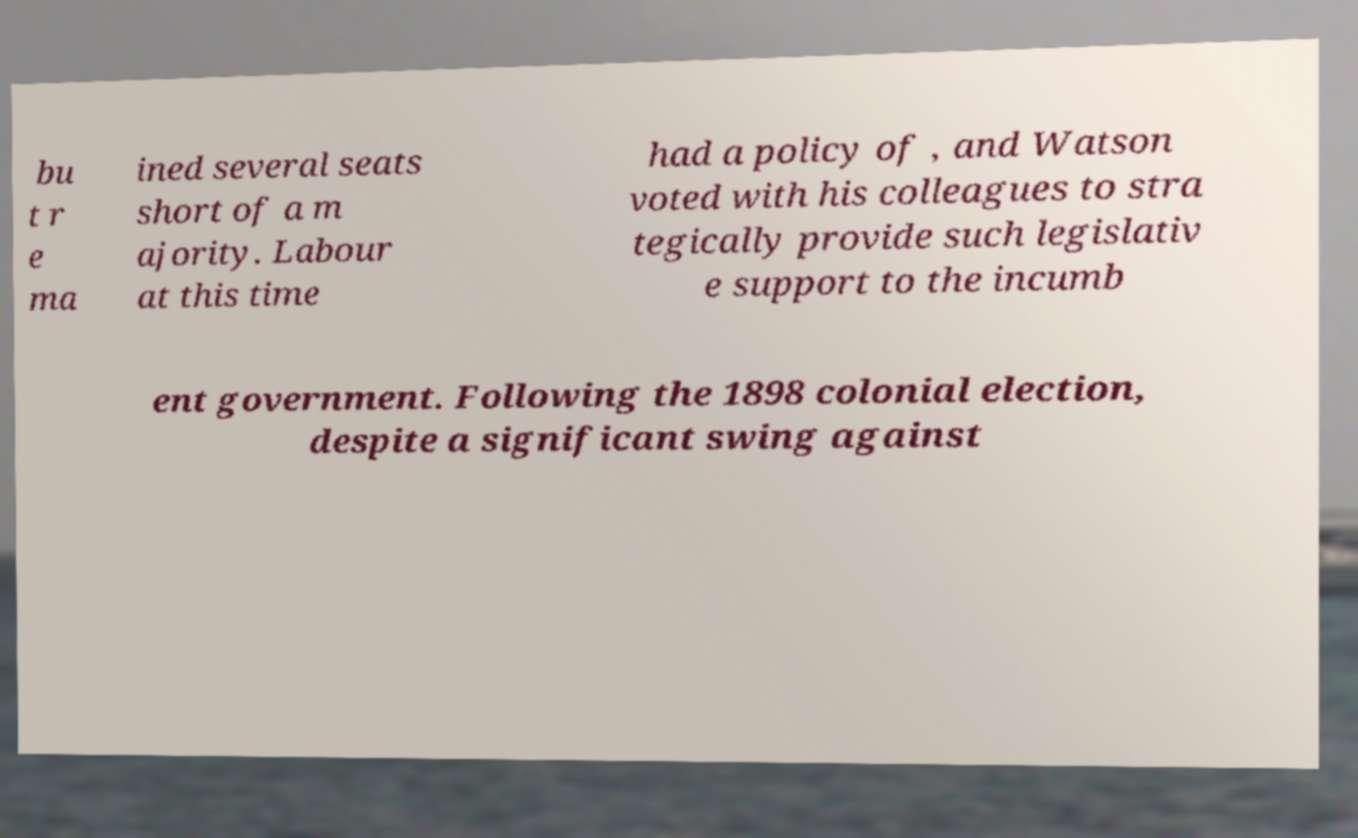Please identify and transcribe the text found in this image. bu t r e ma ined several seats short of a m ajority. Labour at this time had a policy of , and Watson voted with his colleagues to stra tegically provide such legislativ e support to the incumb ent government. Following the 1898 colonial election, despite a significant swing against 